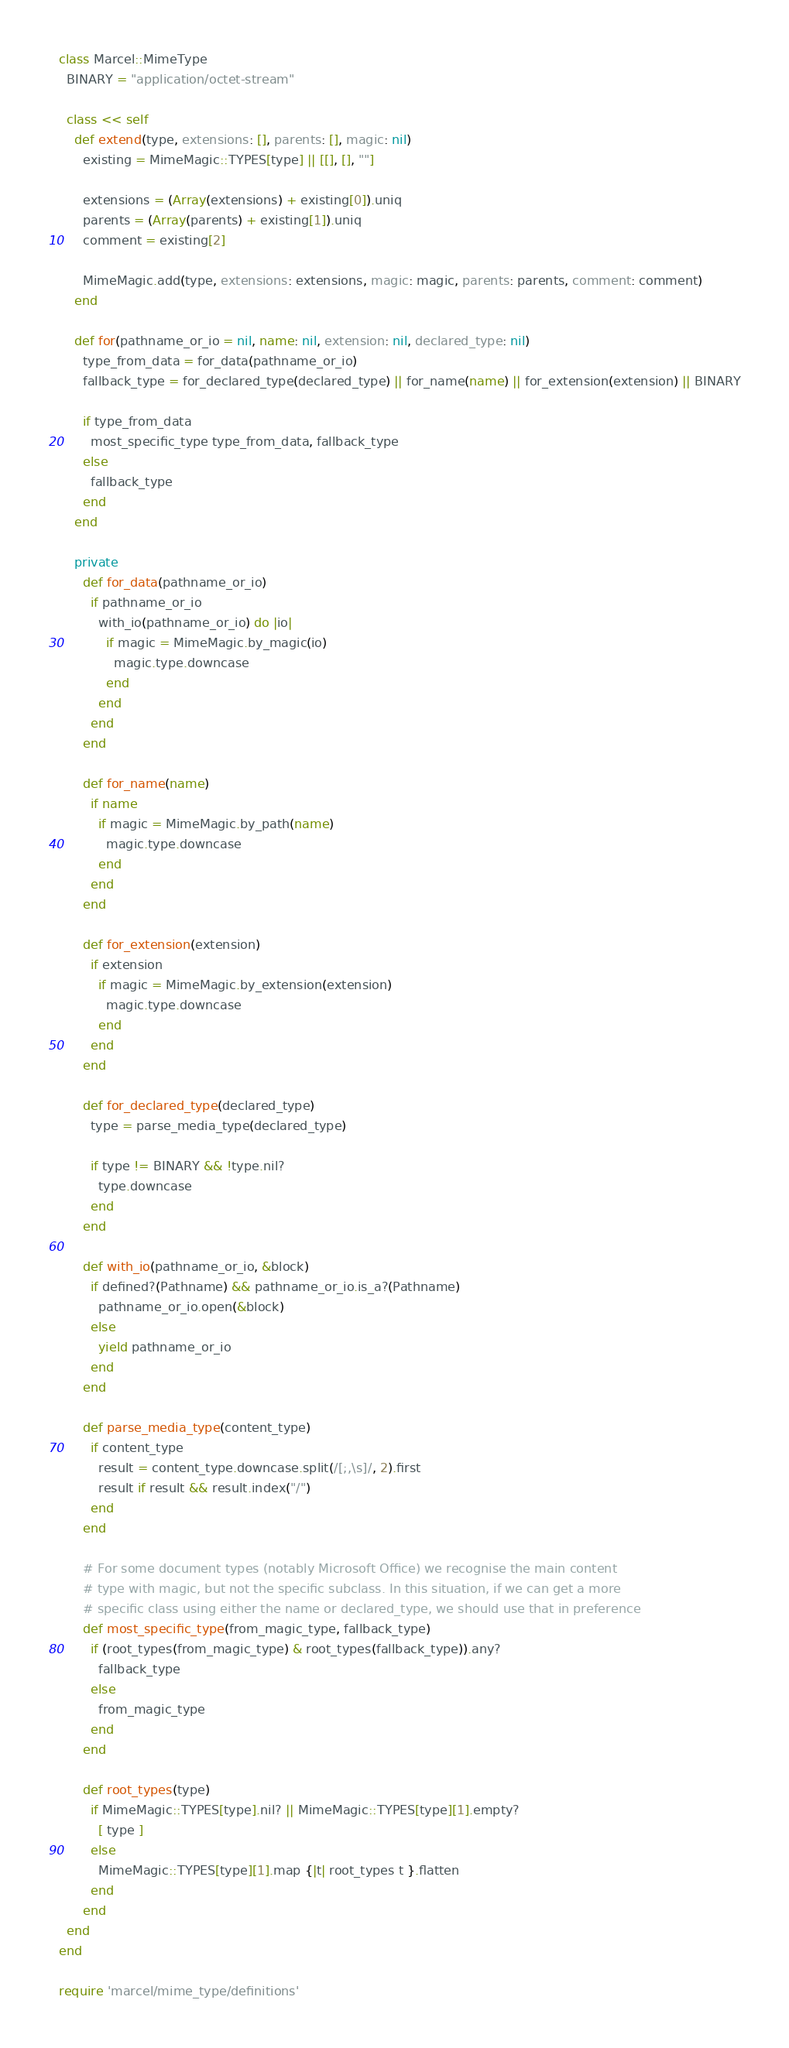<code> <loc_0><loc_0><loc_500><loc_500><_Ruby_>class Marcel::MimeType
  BINARY = "application/octet-stream"

  class << self
    def extend(type, extensions: [], parents: [], magic: nil)
      existing = MimeMagic::TYPES[type] || [[], [], ""]

      extensions = (Array(extensions) + existing[0]).uniq
      parents = (Array(parents) + existing[1]).uniq
      comment = existing[2]

      MimeMagic.add(type, extensions: extensions, magic: magic, parents: parents, comment: comment)
    end

    def for(pathname_or_io = nil, name: nil, extension: nil, declared_type: nil)
      type_from_data = for_data(pathname_or_io)
      fallback_type = for_declared_type(declared_type) || for_name(name) || for_extension(extension) || BINARY

      if type_from_data
        most_specific_type type_from_data, fallback_type
      else
        fallback_type
      end
    end

    private
      def for_data(pathname_or_io)
        if pathname_or_io
          with_io(pathname_or_io) do |io|
            if magic = MimeMagic.by_magic(io)
              magic.type.downcase
            end
          end
        end
      end

      def for_name(name)
        if name
          if magic = MimeMagic.by_path(name)
            magic.type.downcase
          end
        end
      end

      def for_extension(extension)
        if extension
          if magic = MimeMagic.by_extension(extension)
            magic.type.downcase
          end
        end
      end

      def for_declared_type(declared_type)
        type = parse_media_type(declared_type)

        if type != BINARY && !type.nil?
          type.downcase
        end
      end

      def with_io(pathname_or_io, &block)
        if defined?(Pathname) && pathname_or_io.is_a?(Pathname)
          pathname_or_io.open(&block)
        else
          yield pathname_or_io
        end
      end

      def parse_media_type(content_type)
        if content_type
          result = content_type.downcase.split(/[;,\s]/, 2).first
          result if result && result.index("/")
        end
      end

      # For some document types (notably Microsoft Office) we recognise the main content
      # type with magic, but not the specific subclass. In this situation, if we can get a more
      # specific class using either the name or declared_type, we should use that in preference
      def most_specific_type(from_magic_type, fallback_type)
        if (root_types(from_magic_type) & root_types(fallback_type)).any?
          fallback_type
        else
          from_magic_type
        end
      end

      def root_types(type)
        if MimeMagic::TYPES[type].nil? || MimeMagic::TYPES[type][1].empty?
          [ type ]
        else
          MimeMagic::TYPES[type][1].map {|t| root_types t }.flatten
        end
      end
  end
end

require 'marcel/mime_type/definitions'
</code> 